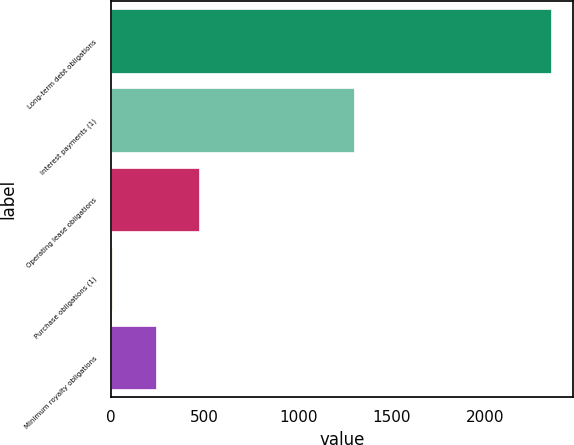Convert chart to OTSL. <chart><loc_0><loc_0><loc_500><loc_500><bar_chart><fcel>Long-term debt obligations<fcel>Interest payments (1)<fcel>Operating lease obligations<fcel>Purchase obligations (1)<fcel>Minimum royalty obligations<nl><fcel>2350<fcel>1300<fcel>471.6<fcel>2<fcel>236.8<nl></chart> 